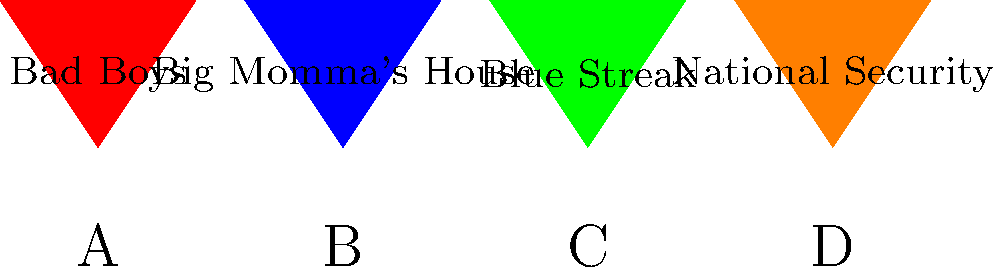In which of the movie posters represented above does Martin Lawrence play a character who disguises himself as an elderly woman? To answer this question, let's analyze each movie poster and Martin Lawrence's role in them:

1. Poster A (Red): "Bad Boys" - In this film, Martin Lawrence plays Marcus Burnett, a detective. He doesn't disguise himself as an elderly woman in this movie.

2. Poster B (Blue): "Big Momma's House" - This is the correct answer. In this movie, Martin Lawrence plays FBI agent Malcolm Turner, who goes undercover by disguising himself as an elderly woman named Big Momma.

3. Poster C (Green): "Blue Streak" - Martin Lawrence plays Miles Logan, a jewel thief posing as a detective. He doesn't disguise himself as an elderly woman in this film.

4. Poster D (Orange): "National Security" - In this movie, Martin Lawrence plays Earl Montgomery, a former police academy trainee working as a security guard. He doesn't disguise himself as an elderly woman in this role.

Therefore, the movie poster that represents Martin Lawrence playing a character who disguises himself as an elderly woman is Poster B, "Big Momma's House."
Answer: B 